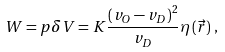<formula> <loc_0><loc_0><loc_500><loc_500>W = p \delta V = K \frac { \left ( v _ { O } - v _ { D } \right ) ^ { 2 } } { v _ { D } } \eta \left ( \vec { r } \right ) \, ,</formula> 